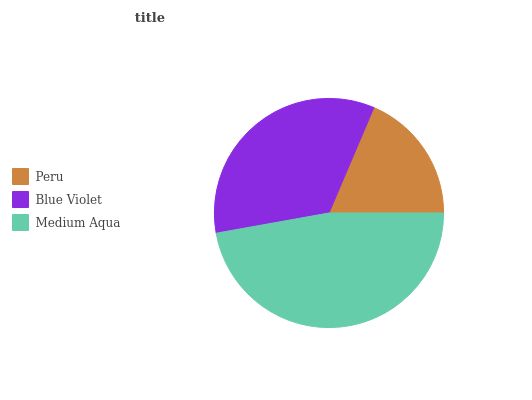Is Peru the minimum?
Answer yes or no. Yes. Is Medium Aqua the maximum?
Answer yes or no. Yes. Is Blue Violet the minimum?
Answer yes or no. No. Is Blue Violet the maximum?
Answer yes or no. No. Is Blue Violet greater than Peru?
Answer yes or no. Yes. Is Peru less than Blue Violet?
Answer yes or no. Yes. Is Peru greater than Blue Violet?
Answer yes or no. No. Is Blue Violet less than Peru?
Answer yes or no. No. Is Blue Violet the high median?
Answer yes or no. Yes. Is Blue Violet the low median?
Answer yes or no. Yes. Is Peru the high median?
Answer yes or no. No. Is Peru the low median?
Answer yes or no. No. 